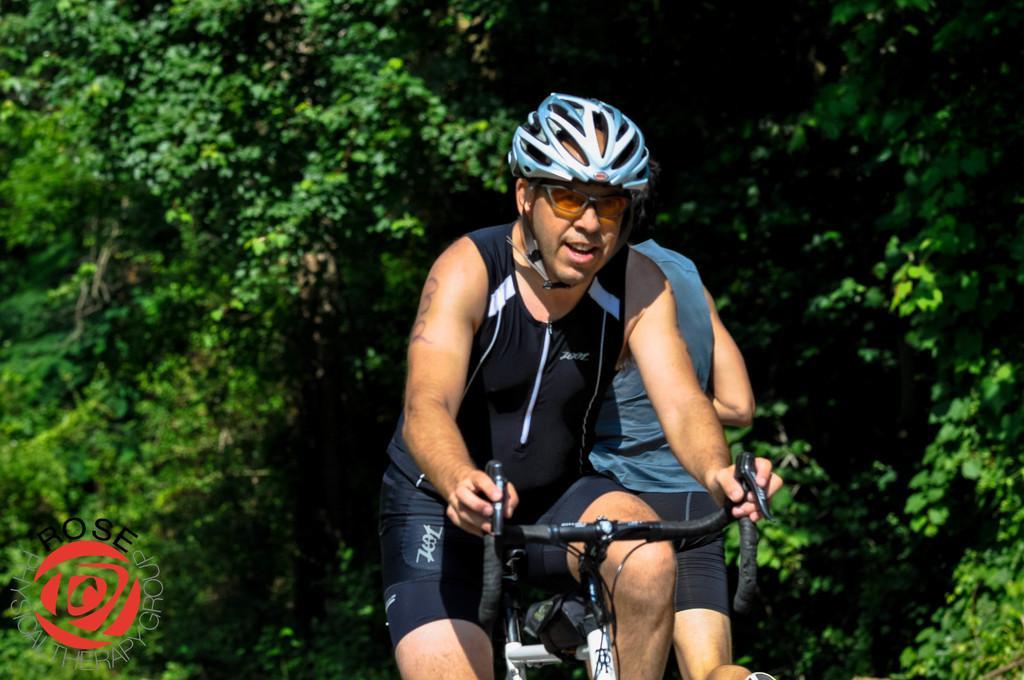How would you summarize this image in a sentence or two? In this image I can see one person riding the bicycle and wearing the helmet. To the side I can see another person. In the background I can see many trees. 